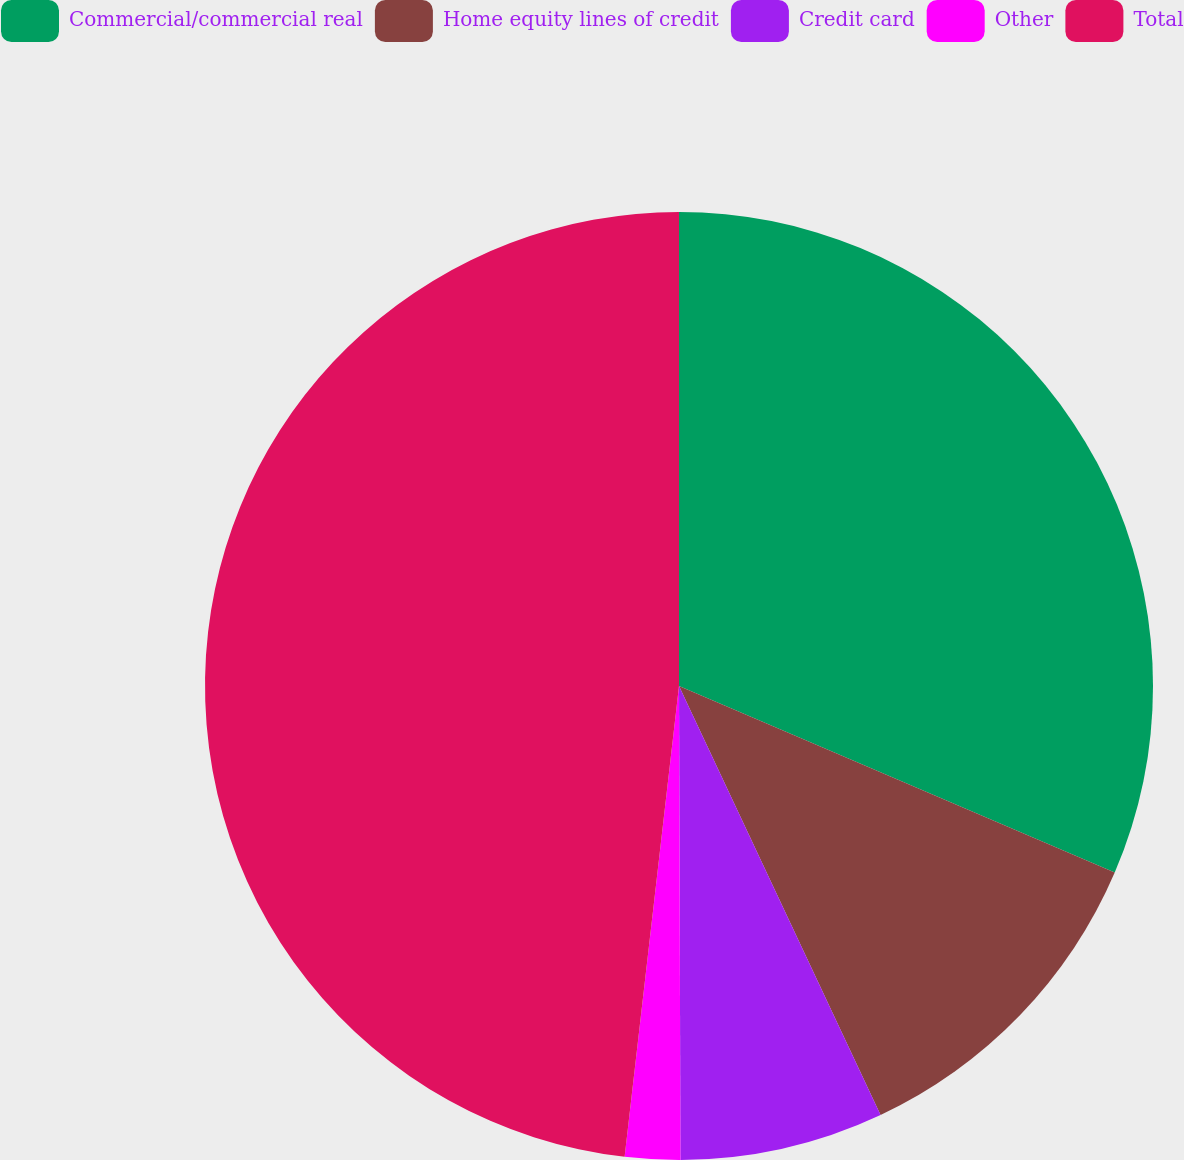Convert chart to OTSL. <chart><loc_0><loc_0><loc_500><loc_500><pie_chart><fcel>Commercial/commercial real<fcel>Home equity lines of credit<fcel>Credit card<fcel>Other<fcel>Total<nl><fcel>31.44%<fcel>11.57%<fcel>6.94%<fcel>1.88%<fcel>48.17%<nl></chart> 